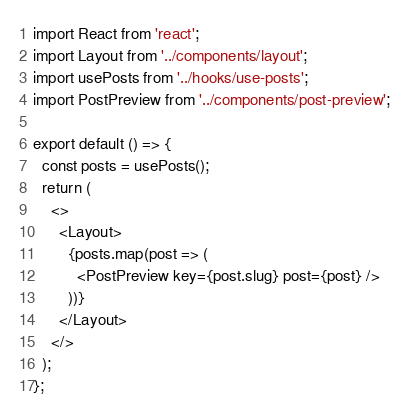Convert code to text. <code><loc_0><loc_0><loc_500><loc_500><_JavaScript_>import React from 'react';
import Layout from '../components/layout';
import usePosts from '../hooks/use-posts';
import PostPreview from '../components/post-preview';

export default () => {
  const posts = usePosts();
  return (
    <>
      <Layout>
        {posts.map(post => (
          <PostPreview key={post.slug} post={post} />
        ))}
      </Layout>
    </>
  );
};
</code> 